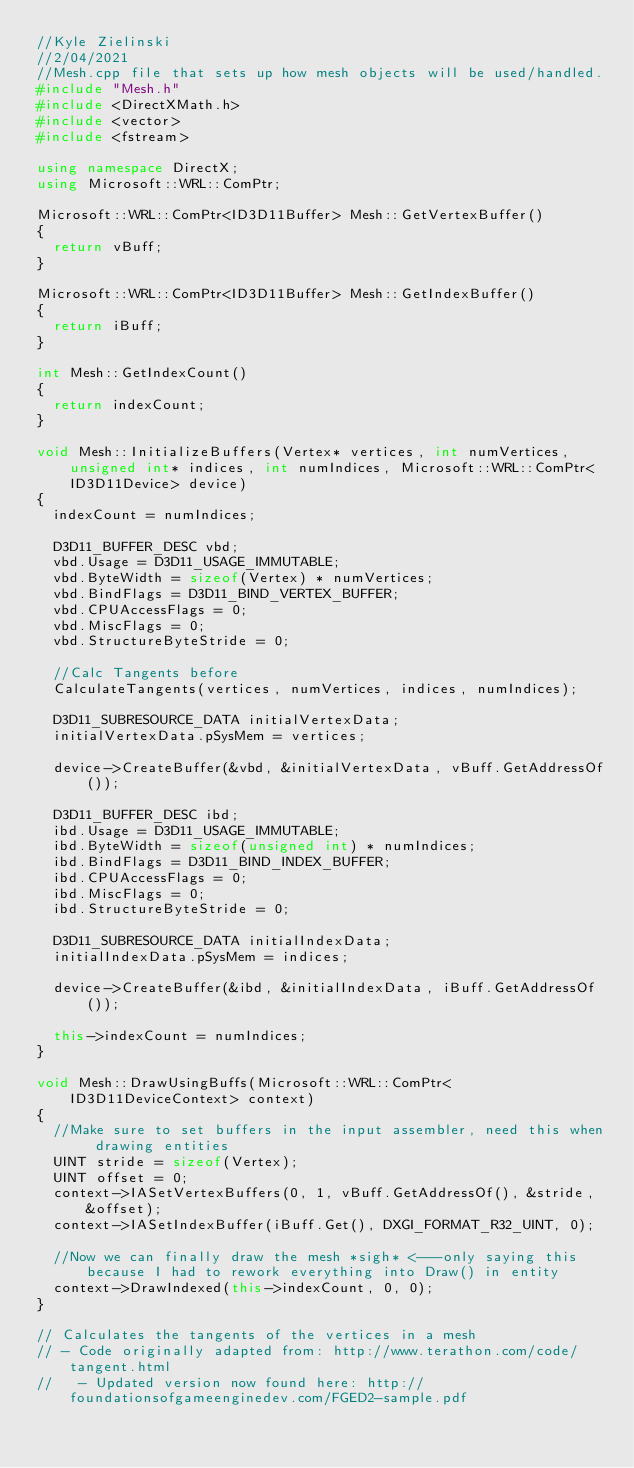<code> <loc_0><loc_0><loc_500><loc_500><_C++_>//Kyle Zielinski
//2/04/2021
//Mesh.cpp file that sets up how mesh objects will be used/handled.
#include "Mesh.h"
#include <DirectXMath.h>
#include <vector>
#include <fstream>

using namespace DirectX;
using Microsoft::WRL::ComPtr;

Microsoft::WRL::ComPtr<ID3D11Buffer> Mesh::GetVertexBuffer()
{
	return vBuff;
}

Microsoft::WRL::ComPtr<ID3D11Buffer> Mesh::GetIndexBuffer()
{
	return iBuff;
}

int Mesh::GetIndexCount()
{
	return indexCount;
}

void Mesh::InitializeBuffers(Vertex* vertices, int numVertices, unsigned int* indices, int numIndices, Microsoft::WRL::ComPtr<ID3D11Device> device)
{
	indexCount = numIndices;

	D3D11_BUFFER_DESC vbd;
	vbd.Usage = D3D11_USAGE_IMMUTABLE;
	vbd.ByteWidth = sizeof(Vertex) * numVertices;
	vbd.BindFlags = D3D11_BIND_VERTEX_BUFFER;
	vbd.CPUAccessFlags = 0;
	vbd.MiscFlags = 0;
	vbd.StructureByteStride = 0;

	//Calc Tangents before 
	CalculateTangents(vertices, numVertices, indices, numIndices);

	D3D11_SUBRESOURCE_DATA initialVertexData;
	initialVertexData.pSysMem = vertices;

	device->CreateBuffer(&vbd, &initialVertexData, vBuff.GetAddressOf());

	D3D11_BUFFER_DESC ibd;
	ibd.Usage = D3D11_USAGE_IMMUTABLE;
	ibd.ByteWidth = sizeof(unsigned int) * numIndices;
	ibd.BindFlags = D3D11_BIND_INDEX_BUFFER;
	ibd.CPUAccessFlags = 0;
	ibd.MiscFlags = 0;
	ibd.StructureByteStride = 0;

	D3D11_SUBRESOURCE_DATA initialIndexData;
	initialIndexData.pSysMem = indices;

	device->CreateBuffer(&ibd, &initialIndexData, iBuff.GetAddressOf());

	this->indexCount = numIndices;
}

void Mesh::DrawUsingBuffs(Microsoft::WRL::ComPtr<ID3D11DeviceContext> context)
{
	//Make sure to set buffers in the input assembler, need this when drawing entities
	UINT stride = sizeof(Vertex);
	UINT offset = 0;
	context->IASetVertexBuffers(0, 1, vBuff.GetAddressOf(), &stride, &offset);
	context->IASetIndexBuffer(iBuff.Get(), DXGI_FORMAT_R32_UINT, 0);

	//Now we can finally draw the mesh *sigh* <---only saying this because I had to rework everything into Draw() in entity 
	context->DrawIndexed(this->indexCount, 0, 0);
}

// Calculates the tangents of the vertices in a mesh
// - Code originally adapted from: http://www.terathon.com/code/tangent.html
//   - Updated version now found here: http://foundationsofgameenginedev.com/FGED2-sample.pdf</code> 